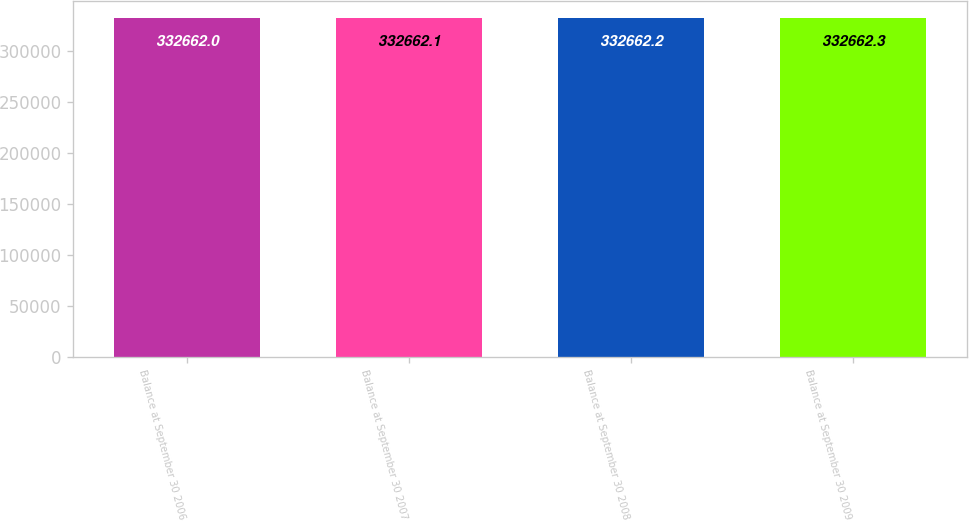Convert chart. <chart><loc_0><loc_0><loc_500><loc_500><bar_chart><fcel>Balance at September 30 2006<fcel>Balance at September 30 2007<fcel>Balance at September 30 2008<fcel>Balance at September 30 2009<nl><fcel>332662<fcel>332662<fcel>332662<fcel>332662<nl></chart> 